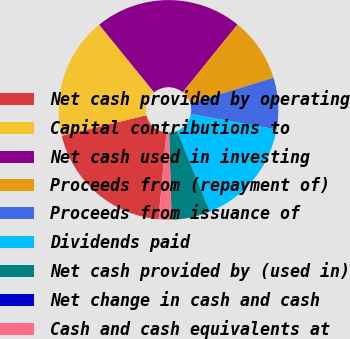<chart> <loc_0><loc_0><loc_500><loc_500><pie_chart><fcel>Net cash provided by operating<fcel>Capital contributions to<fcel>Net cash used in investing<fcel>Proceeds from (repayment of)<fcel>Proceeds from issuance of<fcel>Dividends paid<fcel>Net cash provided by (used in)<fcel>Net change in cash and cash<fcel>Cash and cash equivalents at<nl><fcel>19.79%<fcel>17.9%<fcel>21.68%<fcel>9.46%<fcel>7.57%<fcel>16.01%<fcel>5.68%<fcel>0.0%<fcel>1.9%<nl></chart> 